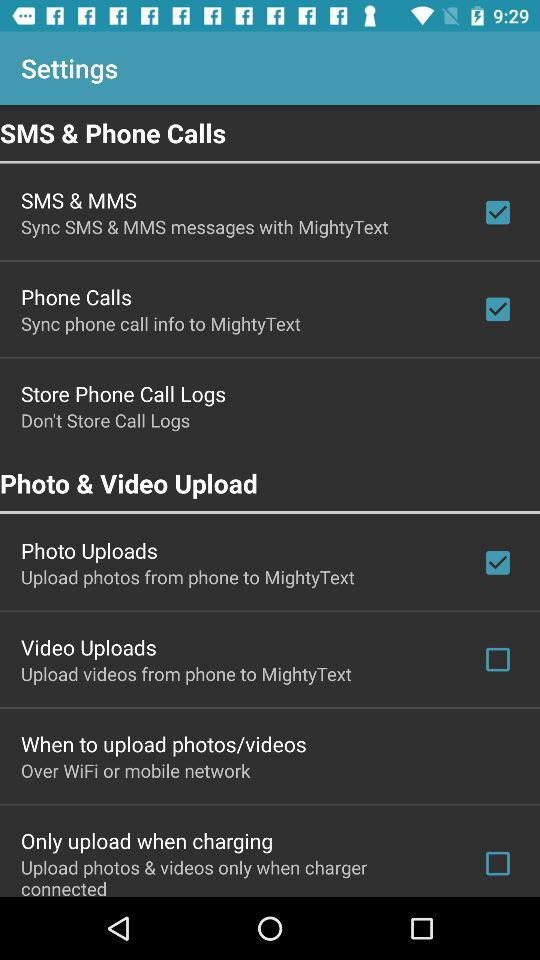What is the status of "Phone Calls"? The status is "on". 